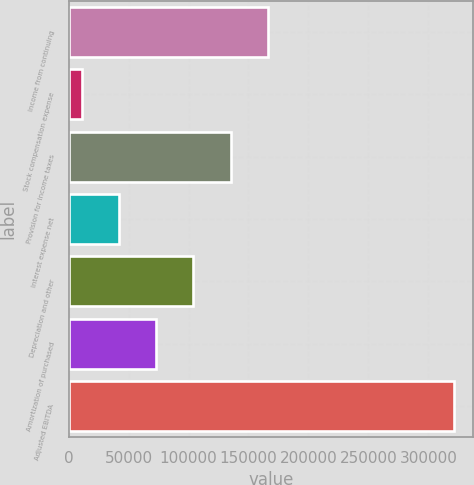Convert chart to OTSL. <chart><loc_0><loc_0><loc_500><loc_500><bar_chart><fcel>Income from continuing<fcel>Stock compensation expense<fcel>Provision for income taxes<fcel>Interest expense net<fcel>Depreciation and other<fcel>Amortization of purchased<fcel>Adjusted EBITDA<nl><fcel>166161<fcel>10961<fcel>135121<fcel>42001<fcel>104081<fcel>73041<fcel>321361<nl></chart> 